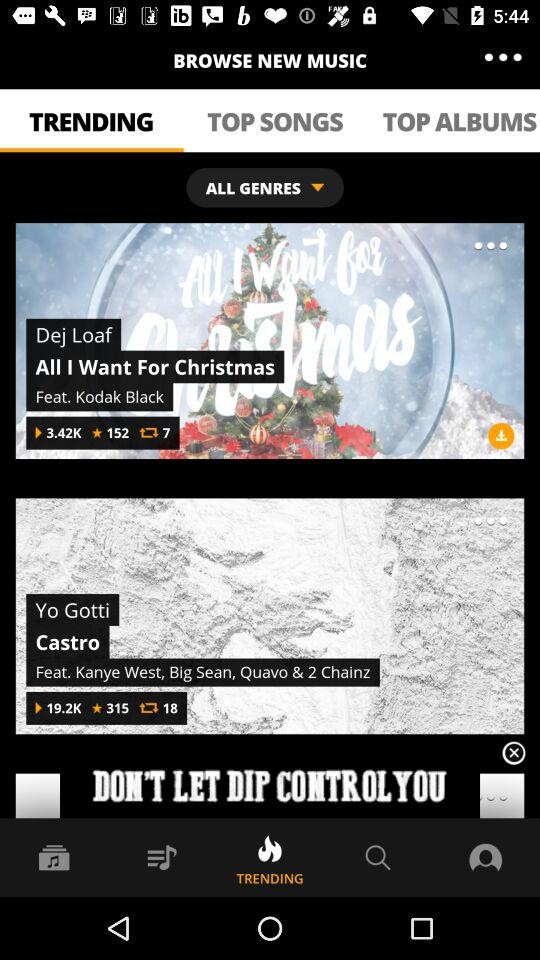Which option is selected for music? The selected option is "TRENDING". 